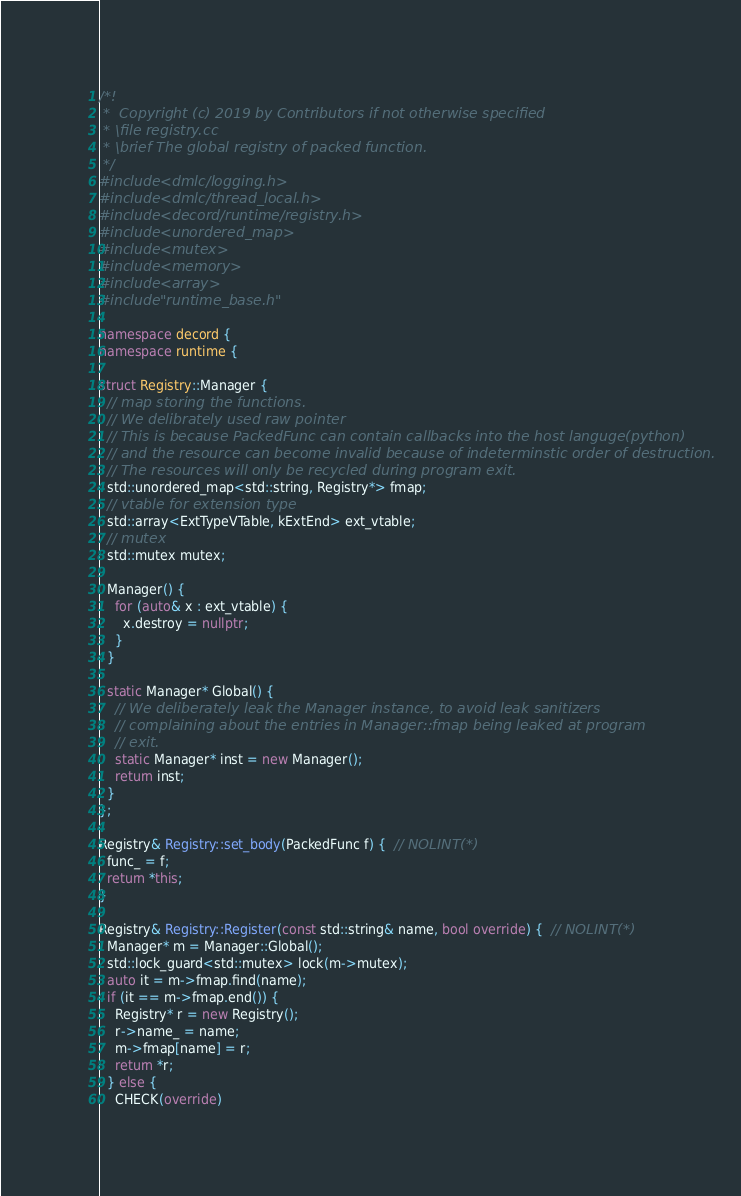Convert code to text. <code><loc_0><loc_0><loc_500><loc_500><_C++_>/*!
 *  Copyright (c) 2019 by Contributors if not otherwise specified
 * \file registry.cc
 * \brief The global registry of packed function.
 */
#include <dmlc/logging.h>
#include <dmlc/thread_local.h>
#include <decord/runtime/registry.h>
#include <unordered_map>
#include <mutex>
#include <memory>
#include <array>
#include "runtime_base.h"

namespace decord {
namespace runtime {

struct Registry::Manager {
  // map storing the functions.
  // We delibrately used raw pointer
  // This is because PackedFunc can contain callbacks into the host languge(python)
  // and the resource can become invalid because of indeterminstic order of destruction.
  // The resources will only be recycled during program exit.
  std::unordered_map<std::string, Registry*> fmap;
  // vtable for extension type
  std::array<ExtTypeVTable, kExtEnd> ext_vtable;
  // mutex
  std::mutex mutex;

  Manager() {
    for (auto& x : ext_vtable) {
      x.destroy = nullptr;
    }
  }

  static Manager* Global() {
    // We deliberately leak the Manager instance, to avoid leak sanitizers
    // complaining about the entries in Manager::fmap being leaked at program
    // exit.
    static Manager* inst = new Manager();
    return inst;
  }
};

Registry& Registry::set_body(PackedFunc f) {  // NOLINT(*)
  func_ = f;
  return *this;
}

Registry& Registry::Register(const std::string& name, bool override) {  // NOLINT(*)
  Manager* m = Manager::Global();
  std::lock_guard<std::mutex> lock(m->mutex);
  auto it = m->fmap.find(name);
  if (it == m->fmap.end()) {
    Registry* r = new Registry();
    r->name_ = name;
    m->fmap[name] = r;
    return *r;
  } else {
    CHECK(override)</code> 